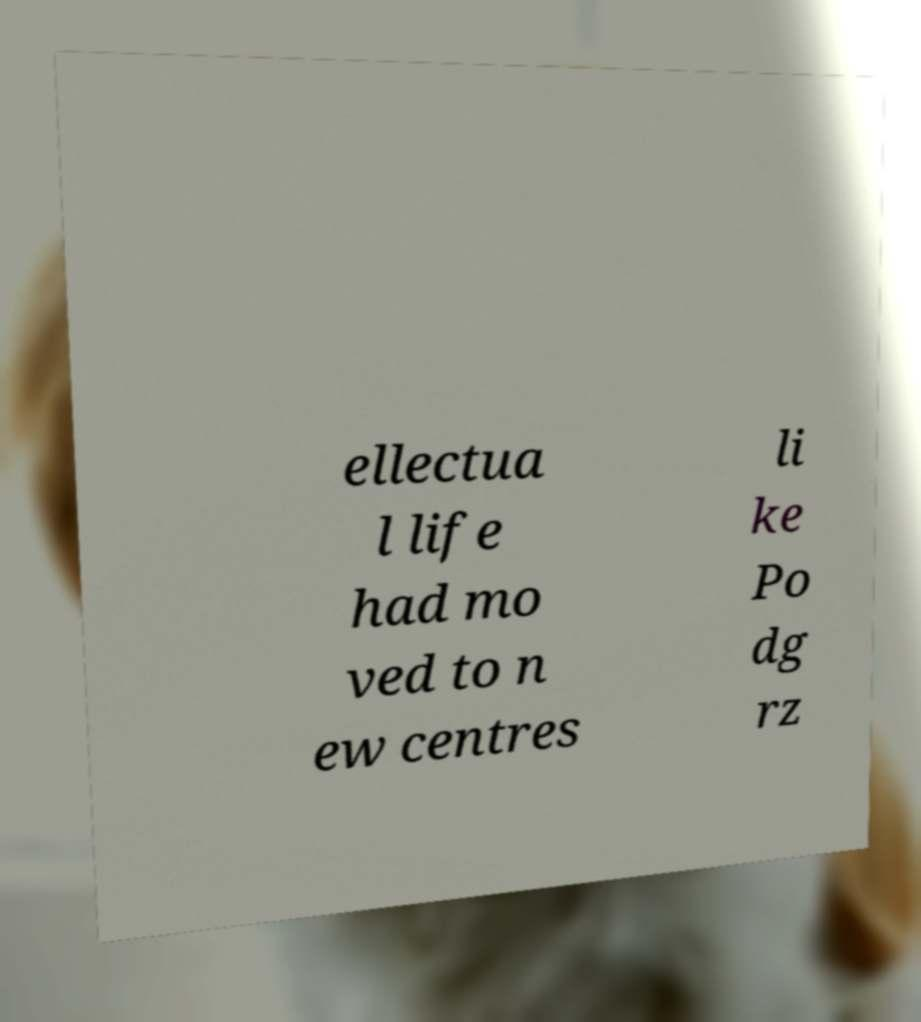Could you assist in decoding the text presented in this image and type it out clearly? ellectua l life had mo ved to n ew centres li ke Po dg rz 